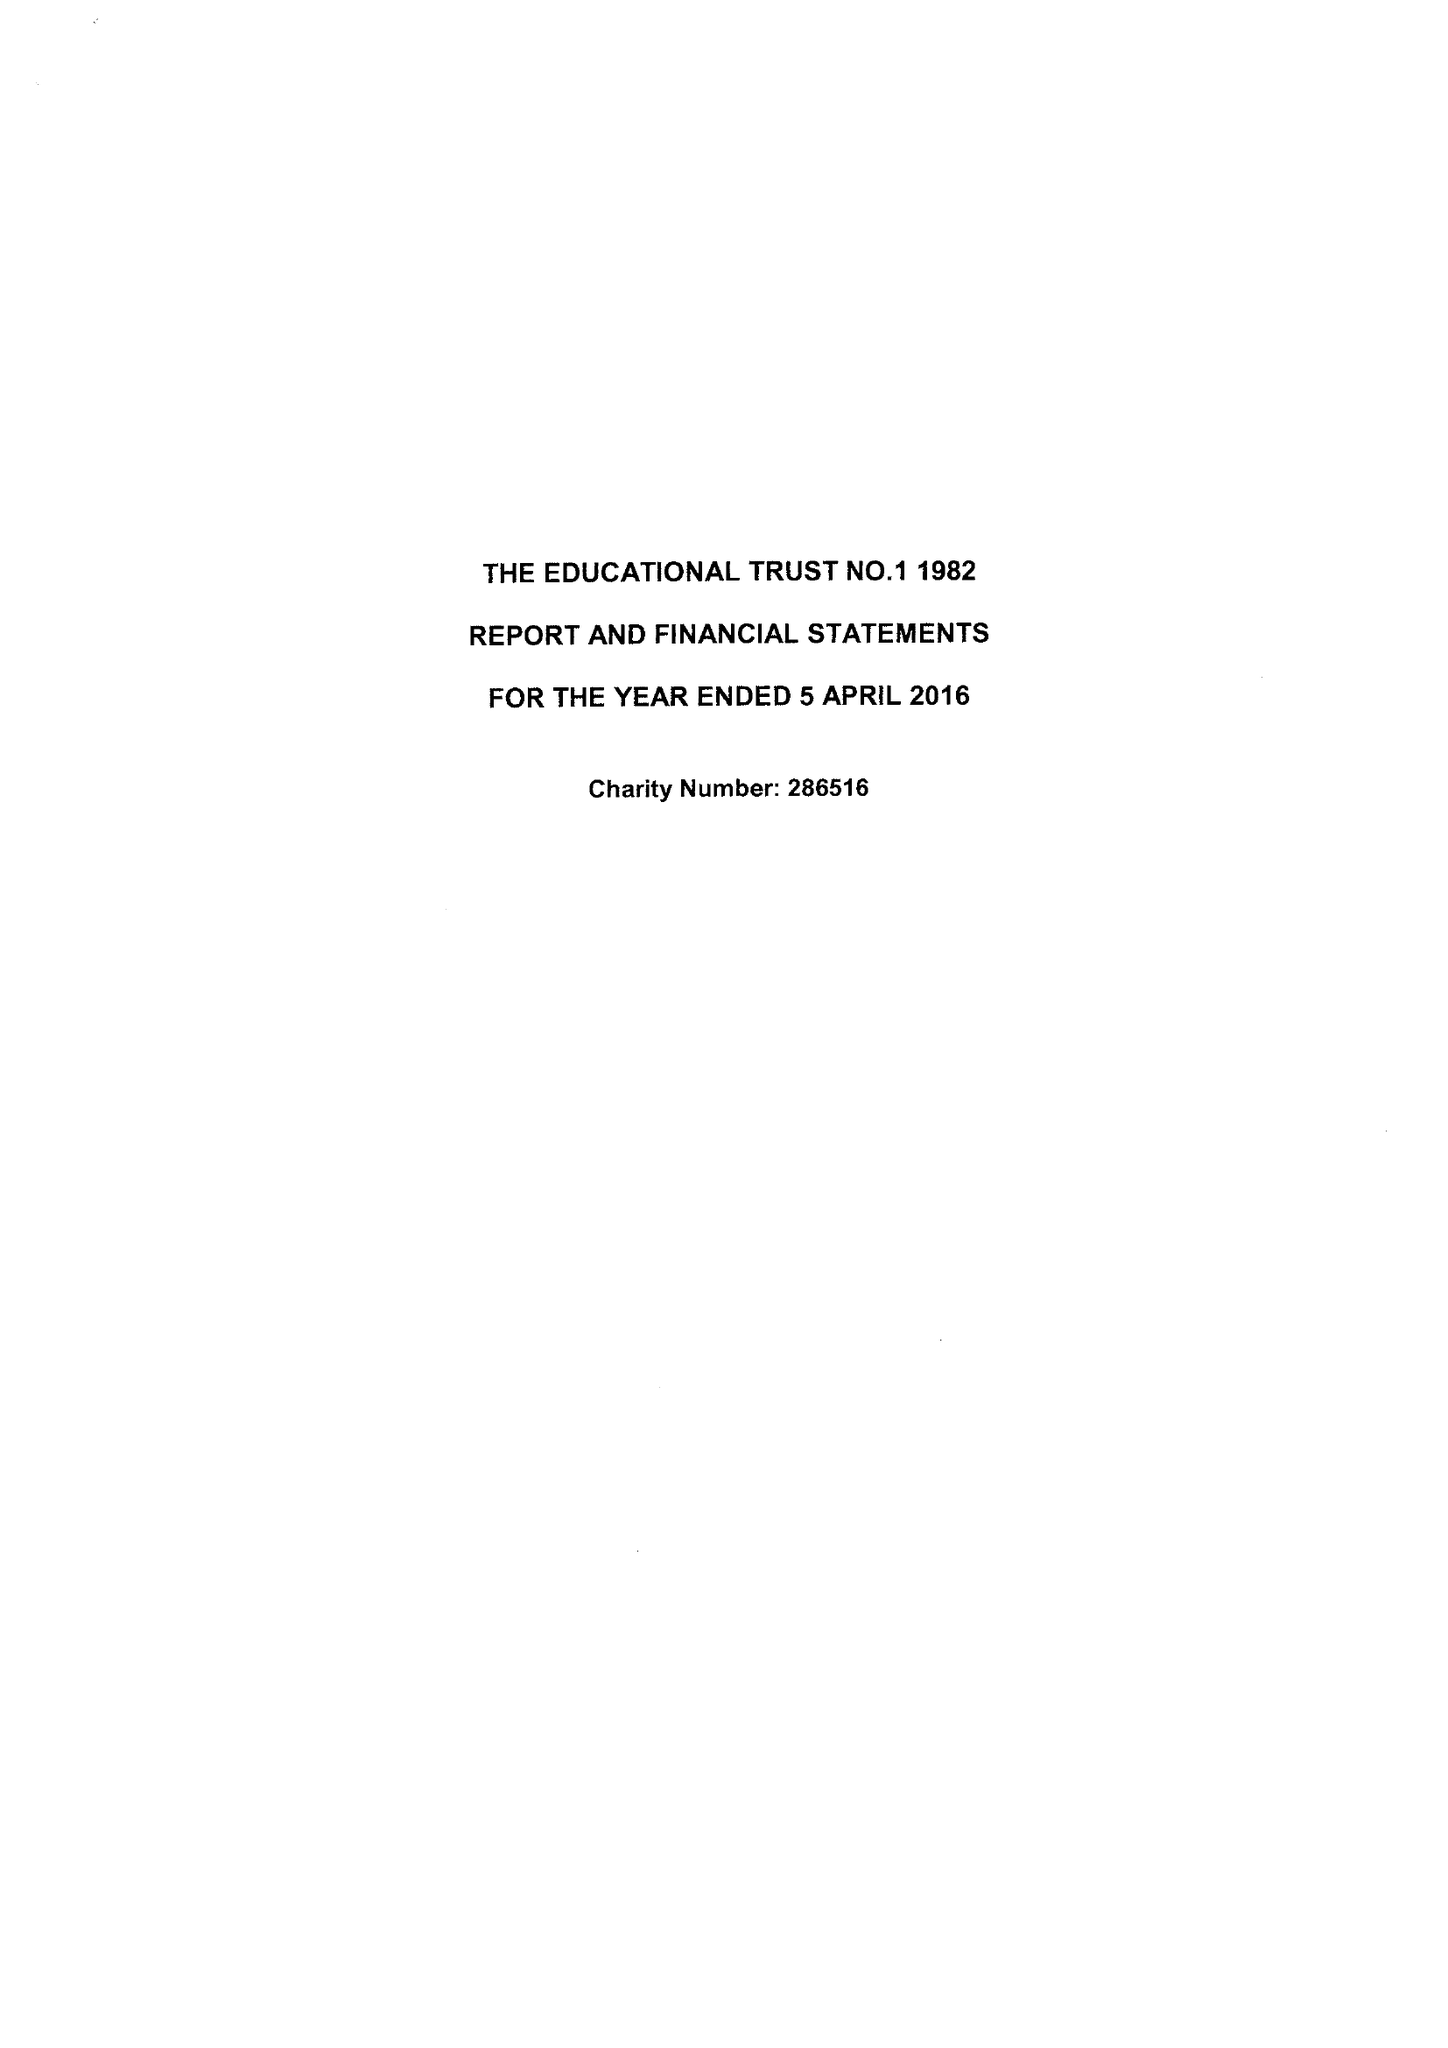What is the value for the address__street_line?
Answer the question using a single word or phrase. THE FORUM PARKWAY 